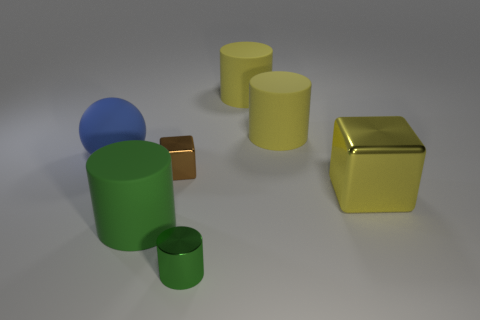The metallic object in front of the large rubber cylinder that is in front of the big metallic thing is what color?
Your answer should be compact. Green. How many tiny objects are yellow matte things or rubber cylinders?
Give a very brief answer. 0. What is the color of the object that is both in front of the large yellow shiny object and on the left side of the small brown block?
Your answer should be very brief. Green. Does the yellow cube have the same material as the blue ball?
Keep it short and to the point. No. What is the shape of the small brown metallic thing?
Provide a short and direct response. Cube. There is a green object in front of the matte cylinder that is in front of the blue thing; what number of shiny cubes are on the left side of it?
Provide a short and direct response. 1. What is the color of the other object that is the same shape as the tiny brown thing?
Make the answer very short. Yellow. There is a large rubber object in front of the big matte thing that is left of the rubber cylinder that is in front of the large blue matte thing; what is its shape?
Offer a very short reply. Cylinder. How big is the matte thing that is both left of the tiny block and to the right of the blue matte sphere?
Your answer should be compact. Large. Is the number of big blue metal balls less than the number of green things?
Make the answer very short. Yes. 